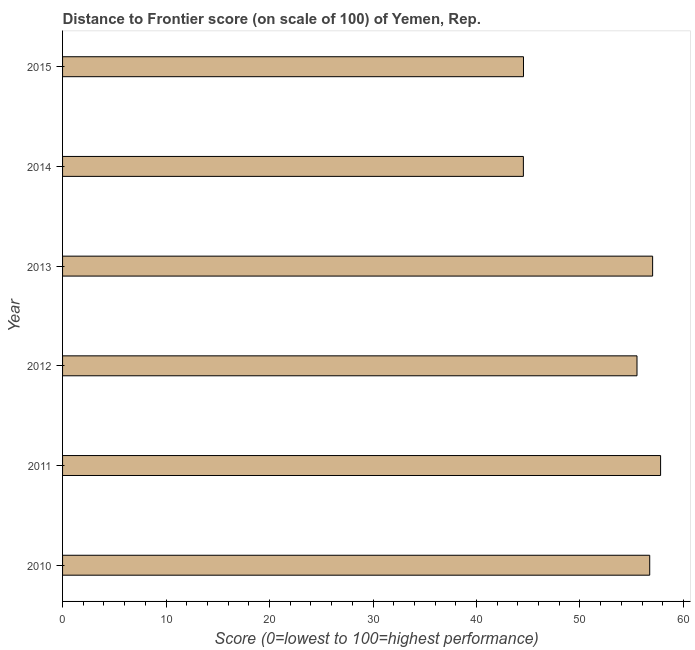What is the title of the graph?
Offer a terse response. Distance to Frontier score (on scale of 100) of Yemen, Rep. What is the label or title of the X-axis?
Ensure brevity in your answer.  Score (0=lowest to 100=highest performance). What is the distance to frontier score in 2012?
Provide a succinct answer. 55.51. Across all years, what is the maximum distance to frontier score?
Give a very brief answer. 57.79. Across all years, what is the minimum distance to frontier score?
Offer a terse response. 44.53. What is the sum of the distance to frontier score?
Give a very brief answer. 316.13. What is the difference between the distance to frontier score in 2011 and 2014?
Your answer should be very brief. 13.26. What is the average distance to frontier score per year?
Your answer should be compact. 52.69. What is the median distance to frontier score?
Make the answer very short. 56.12. In how many years, is the distance to frontier score greater than 14 ?
Ensure brevity in your answer.  6. Do a majority of the years between 2014 and 2011 (inclusive) have distance to frontier score greater than 44 ?
Make the answer very short. Yes. What is the ratio of the distance to frontier score in 2012 to that in 2015?
Make the answer very short. 1.25. Is the difference between the distance to frontier score in 2011 and 2013 greater than the difference between any two years?
Your answer should be compact. No. What is the difference between the highest and the second highest distance to frontier score?
Ensure brevity in your answer.  0.77. Is the sum of the distance to frontier score in 2013 and 2014 greater than the maximum distance to frontier score across all years?
Give a very brief answer. Yes. What is the difference between the highest and the lowest distance to frontier score?
Your response must be concise. 13.26. In how many years, is the distance to frontier score greater than the average distance to frontier score taken over all years?
Your answer should be compact. 4. How many bars are there?
Make the answer very short. 6. What is the difference between two consecutive major ticks on the X-axis?
Offer a very short reply. 10. Are the values on the major ticks of X-axis written in scientific E-notation?
Make the answer very short. No. What is the Score (0=lowest to 100=highest performance) in 2010?
Offer a very short reply. 56.74. What is the Score (0=lowest to 100=highest performance) of 2011?
Offer a very short reply. 57.79. What is the Score (0=lowest to 100=highest performance) in 2012?
Ensure brevity in your answer.  55.51. What is the Score (0=lowest to 100=highest performance) in 2013?
Your answer should be very brief. 57.02. What is the Score (0=lowest to 100=highest performance) of 2014?
Provide a short and direct response. 44.53. What is the Score (0=lowest to 100=highest performance) of 2015?
Give a very brief answer. 44.54. What is the difference between the Score (0=lowest to 100=highest performance) in 2010 and 2011?
Provide a succinct answer. -1.05. What is the difference between the Score (0=lowest to 100=highest performance) in 2010 and 2012?
Provide a succinct answer. 1.23. What is the difference between the Score (0=lowest to 100=highest performance) in 2010 and 2013?
Your answer should be compact. -0.28. What is the difference between the Score (0=lowest to 100=highest performance) in 2010 and 2014?
Your answer should be compact. 12.21. What is the difference between the Score (0=lowest to 100=highest performance) in 2010 and 2015?
Offer a very short reply. 12.2. What is the difference between the Score (0=lowest to 100=highest performance) in 2011 and 2012?
Give a very brief answer. 2.28. What is the difference between the Score (0=lowest to 100=highest performance) in 2011 and 2013?
Your answer should be compact. 0.77. What is the difference between the Score (0=lowest to 100=highest performance) in 2011 and 2014?
Your answer should be compact. 13.26. What is the difference between the Score (0=lowest to 100=highest performance) in 2011 and 2015?
Make the answer very short. 13.25. What is the difference between the Score (0=lowest to 100=highest performance) in 2012 and 2013?
Provide a short and direct response. -1.51. What is the difference between the Score (0=lowest to 100=highest performance) in 2012 and 2014?
Ensure brevity in your answer.  10.98. What is the difference between the Score (0=lowest to 100=highest performance) in 2012 and 2015?
Your response must be concise. 10.97. What is the difference between the Score (0=lowest to 100=highest performance) in 2013 and 2014?
Offer a very short reply. 12.49. What is the difference between the Score (0=lowest to 100=highest performance) in 2013 and 2015?
Ensure brevity in your answer.  12.48. What is the difference between the Score (0=lowest to 100=highest performance) in 2014 and 2015?
Keep it short and to the point. -0.01. What is the ratio of the Score (0=lowest to 100=highest performance) in 2010 to that in 2014?
Your answer should be compact. 1.27. What is the ratio of the Score (0=lowest to 100=highest performance) in 2010 to that in 2015?
Offer a very short reply. 1.27. What is the ratio of the Score (0=lowest to 100=highest performance) in 2011 to that in 2012?
Give a very brief answer. 1.04. What is the ratio of the Score (0=lowest to 100=highest performance) in 2011 to that in 2013?
Offer a terse response. 1.01. What is the ratio of the Score (0=lowest to 100=highest performance) in 2011 to that in 2014?
Your answer should be compact. 1.3. What is the ratio of the Score (0=lowest to 100=highest performance) in 2011 to that in 2015?
Your response must be concise. 1.3. What is the ratio of the Score (0=lowest to 100=highest performance) in 2012 to that in 2014?
Provide a succinct answer. 1.25. What is the ratio of the Score (0=lowest to 100=highest performance) in 2012 to that in 2015?
Your answer should be very brief. 1.25. What is the ratio of the Score (0=lowest to 100=highest performance) in 2013 to that in 2014?
Your answer should be very brief. 1.28. What is the ratio of the Score (0=lowest to 100=highest performance) in 2013 to that in 2015?
Give a very brief answer. 1.28. 